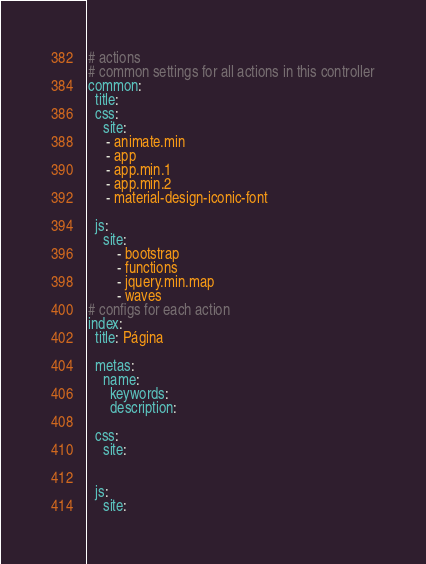<code> <loc_0><loc_0><loc_500><loc_500><_YAML_># actions
# common settings for all actions in this controller
common:
  title:
  css:
    site:
     - animate.min
     - app
     - app.min.1
     - app.min.2
     - material-design-iconic-font

  js:
    site:
        - bootstrap
        - functions
        - jquery.min.map
        - waves
# configs for each action
index:
  title: Página

  metas:
    name:
      keywords:
      description:

  css:
    site:


  js:
    site:

</code> 